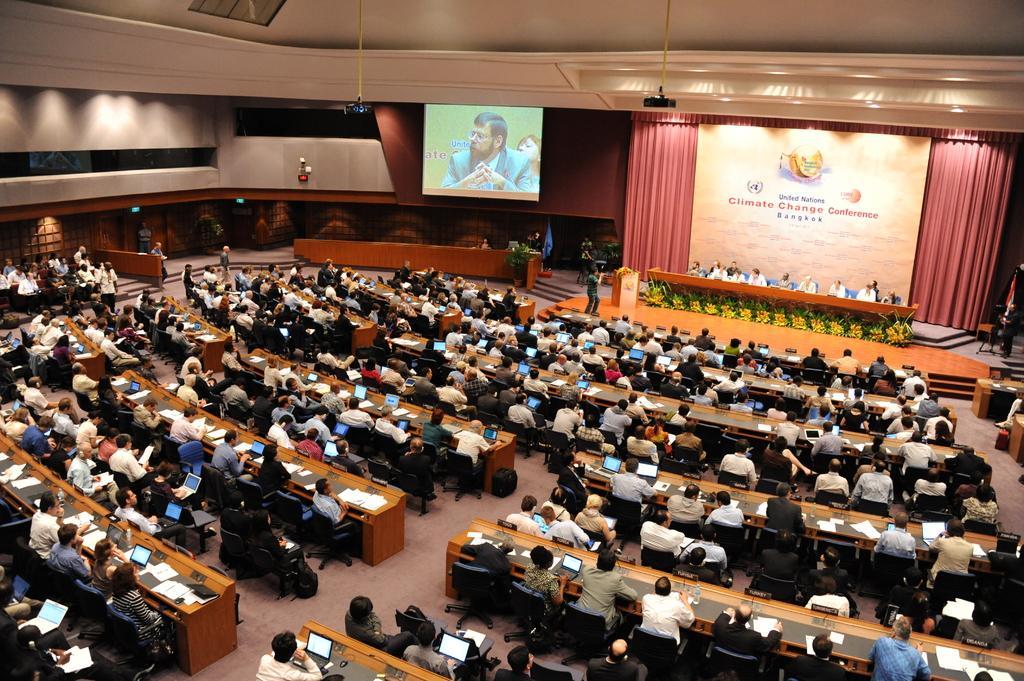Please provide a concise description of this image. In this picture I can see the inside view of the auditorium. At the bottom I can see many peoples were sitting on the chair near to the table. On the table I can see the papers, mouse, laptops, bags, water bottles, water glass and other objects. On the right I can see some group of peoples were sitting on the stage. Beside them there is a cameraman who is standing near to the speech desk. Behind them I can see the banner and red cloth. In the top there is a projector screen. In which I can see the person who is sitting near to the table. On the top right there is a projector machine. On the left I can see some people were sitting near to the exit door. on the right I can see the flag near to the stairs. In the top left corner I can see the light beams. 